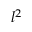Convert formula to latex. <formula><loc_0><loc_0><loc_500><loc_500>l ^ { 2 }</formula> 